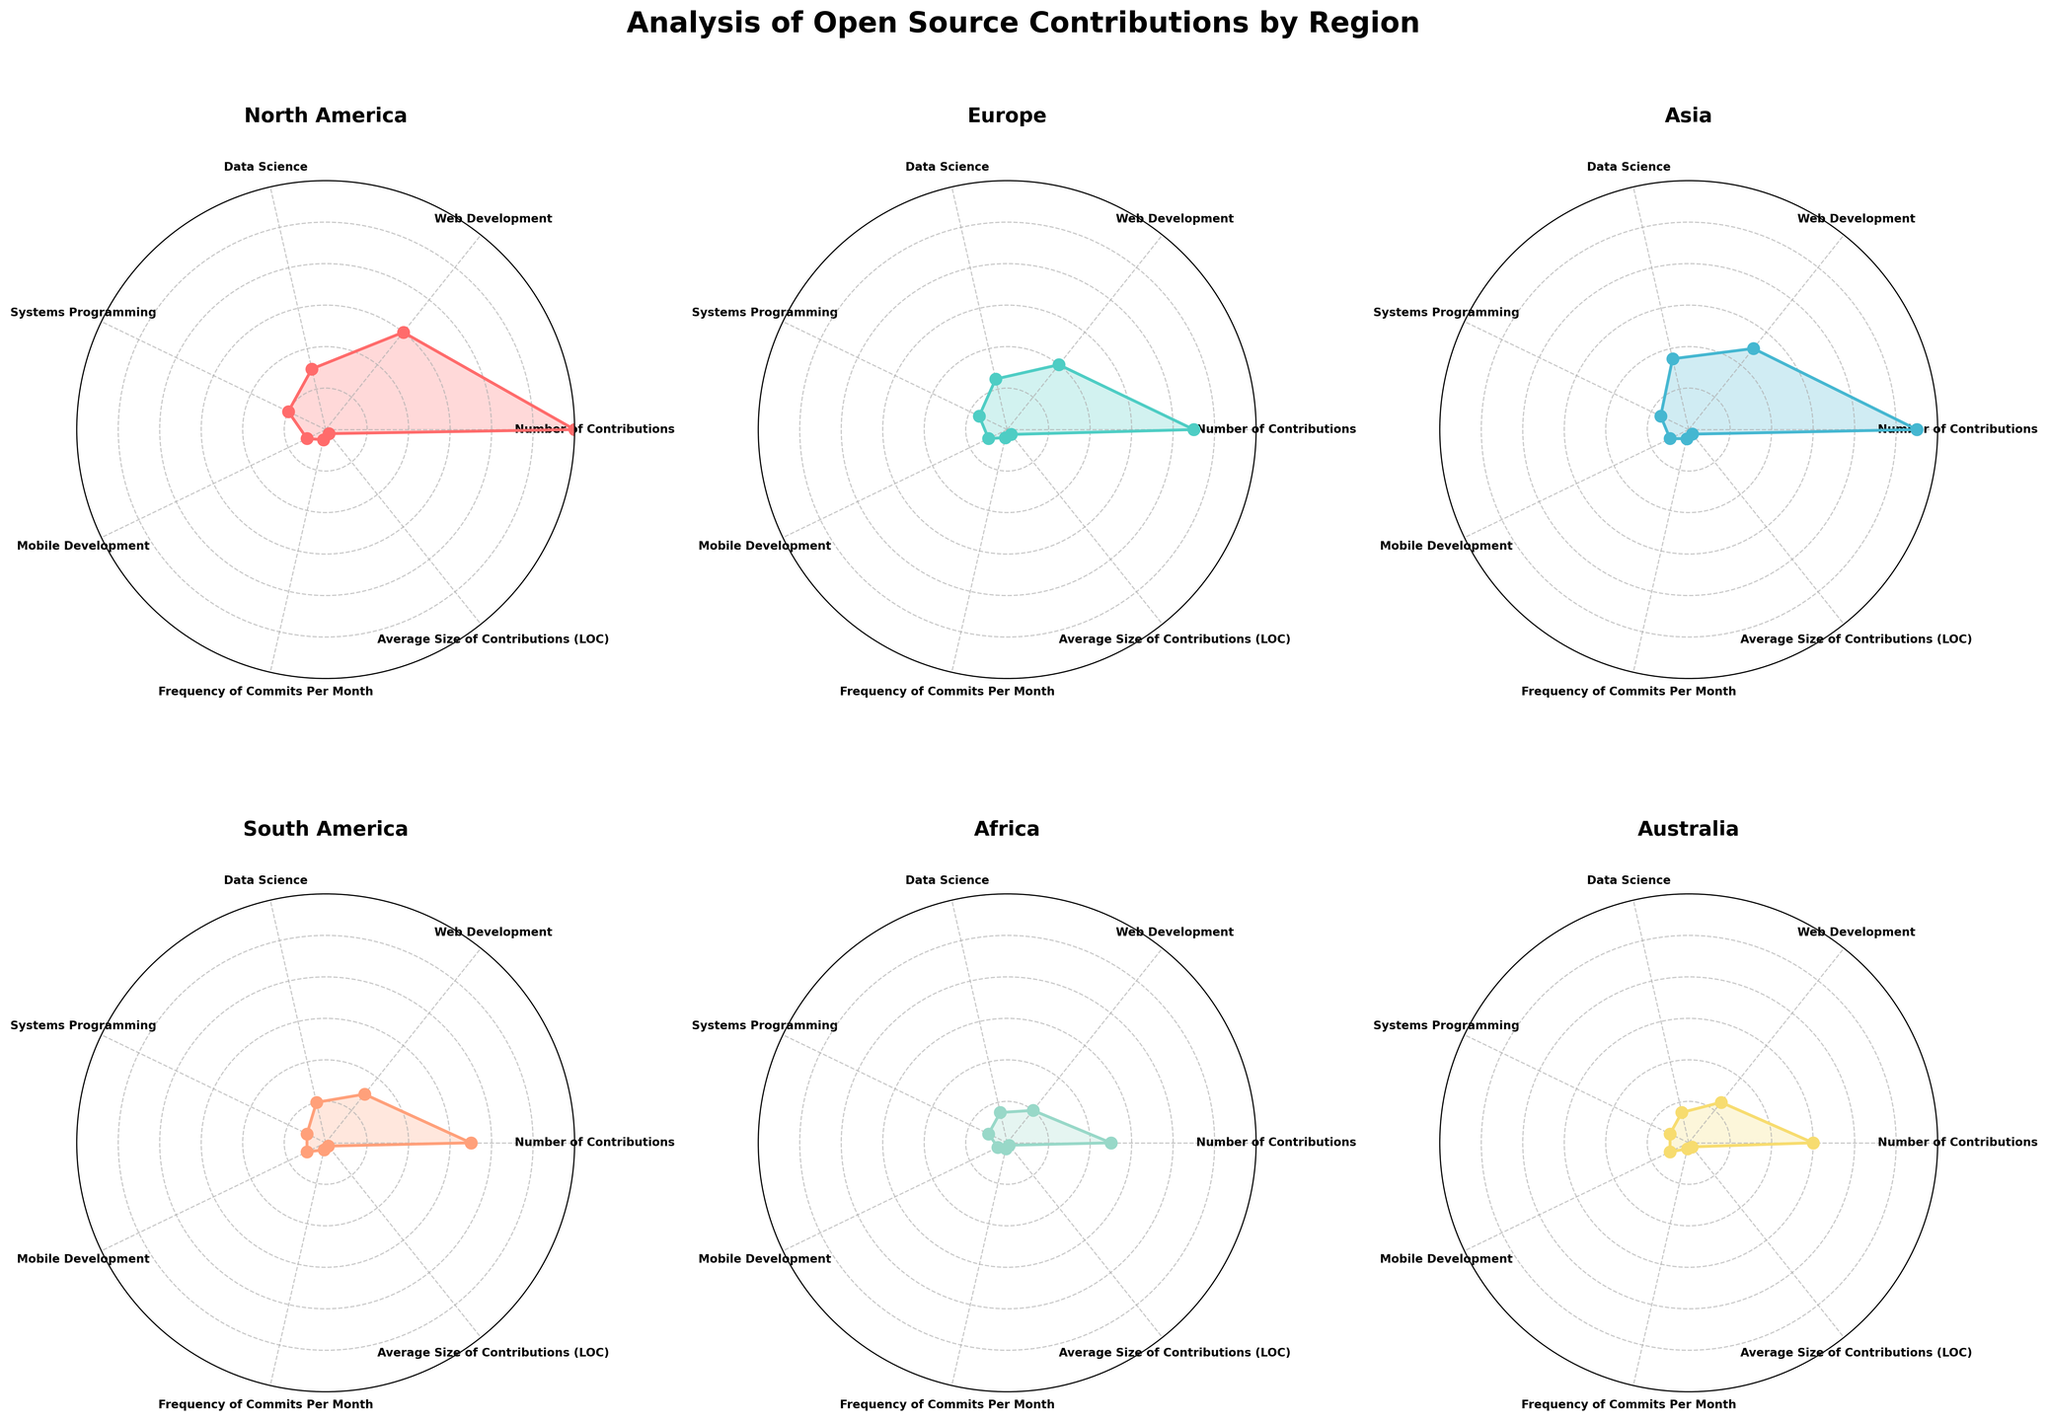Which region has the highest number of total contributions? By looking at the radar chart figure, we observe that North America has the furthest radial distance in the 'Number of Contributions' category, implying it has the highest number of contributions.
Answer: North America Which region contributes the most to Web Development? The radar chart shows the Web Development category with the highest radial distance for North America among all regions.
Answer: North America What is the frequency of commits per month in Asia compared to South America? Observing the 'Frequency of Commits Per Month' axis, Asia has a higher radial distance compared to South America, indicating that the frequency of commits in Asia is higher.
Answer: Asia In which region is the average size of contributions largest? By inspecting the 'Average Size of Contributions (LOC)' axis, Europe has the largest radial distance indicating it has the largest average contribution size.
Answer: Europe How does Systems Programming contributions in North America compare to Europe? In the radar chart, we can see that the radial distance for Systems Programming in North America is slightly greater than that in Europe. Therefore, North America contributes more to Systems Programming than Europe.
Answer: North America Which category shows the smallest differences in contributions across all regions? By analyzing the radar plot, the Mobile Development category lines are the closest to each other among different regions, showing the smallest differences across regions.
Answer: Mobile Development Compare the number of contributions in Australia to those in Africa. Which is larger, and by how much? The chart shows a larger radial distance for 'Number of Contributions' in Australia compared to Africa. Australia has 600 contributions and Africa has 500, so the difference is 100.
Answer: Australia, by 100 Which region has the lowest frequency of commits per month? Looking at the 'Frequency of Commits Per Month' axis across all regions, Australia and Africa both have the smallest radial distance, indicating they have the lowest frequency of commits per month.
Answer: Australia and Africa By how much does North America lead Europe in Data Science contributions? In the radar chart, North America has a higher radial distance for Data Science, showing 300 contributions compared to Europe’s 250. The lead is thus 300 - 250 = 50 contributions.
Answer: 50 What is the average size of contributions in South America? The radar chart indicates that for South America, the radial distance in the 'Average Size of Contributions (LOC)' category corresponds to 20 LOC.
Answer: 20 LOC 